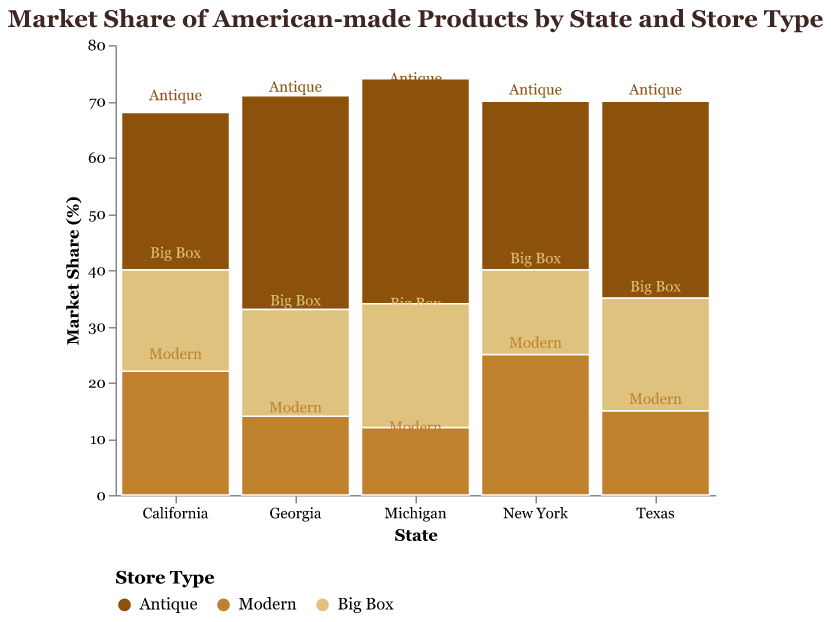what is the title of the figure? The title of the figure is displayed at the top and it reads "Market Share of American-made Products by State and Store Type".
Answer: Market Share of American-made Products by State and Store Type Which state has the highest market share of American-made products in Antique stores? By observing the heights of the Antique segments across different states, Michigan has the highest market share in Antique stores.
Answer: Michigan What is the total market share of American-made products in New York? To find the total market share for New York, we sum the market shares of all store types within New York: 30 (Antique) + 25 (Modern) + 15 (Big Box) = 70.
Answer: 70 How does the market share of Modern stores in California compare to that in Texas? According to the plot, California has a market share of 22% in Modern stores, while Texas has 15%. Therefore, California has a higher market share in Modern stores compared to Texas.
Answer: California has higher market share Which store type has the lowest market share in Georgia? By examining the segments for Georgia, the Modern store type has the smallest height, indicating it has the lowest market share at 14%.
Answer: Modern In which state do Big Box stores have the same market share as Modern stores? From the plot, in Texas, both Big Box and Modern stores have equal market shares of 20%.
Answer: Texas What is the combined market share of Modern stores in all states? Sum the market shares of Modern stores in each state: 15 (Texas) + 22 (California) + 25 (New York) + 12 (Michigan) + 14 (Georgia) = 88.
Answer: 88 Which state has the most balanced distribution of market shares among the three store types? By comparing the height of the segments within each state, California appears the most balanced with market shares: 28 (Antique), 22 (Modern), and 18 (Big Box).
Answer: California 